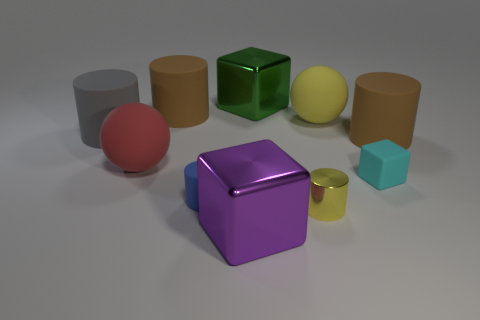Subtract all big cubes. How many cubes are left? 1 Subtract 5 cylinders. How many cylinders are left? 0 Subtract all red spheres. How many brown cylinders are left? 2 Subtract all yellow spheres. How many spheres are left? 1 Subtract all balls. How many objects are left? 8 Subtract 0 blue spheres. How many objects are left? 10 Subtract all purple cubes. Subtract all yellow balls. How many cubes are left? 2 Subtract all red rubber things. Subtract all matte things. How many objects are left? 2 Add 6 tiny cyan things. How many tiny cyan things are left? 7 Add 2 tiny gray shiny objects. How many tiny gray shiny objects exist? 2 